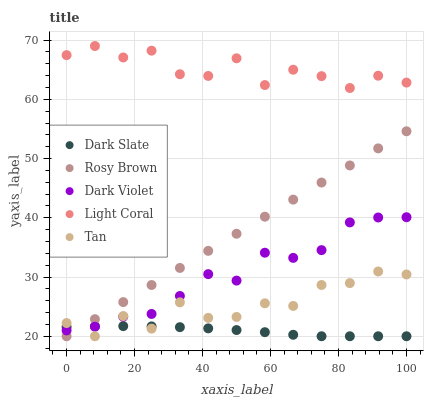Does Dark Slate have the minimum area under the curve?
Answer yes or no. Yes. Does Light Coral have the maximum area under the curve?
Answer yes or no. Yes. Does Tan have the minimum area under the curve?
Answer yes or no. No. Does Tan have the maximum area under the curve?
Answer yes or no. No. Is Rosy Brown the smoothest?
Answer yes or no. Yes. Is Light Coral the roughest?
Answer yes or no. Yes. Is Dark Slate the smoothest?
Answer yes or no. No. Is Dark Slate the roughest?
Answer yes or no. No. Does Dark Slate have the lowest value?
Answer yes or no. Yes. Does Dark Violet have the lowest value?
Answer yes or no. No. Does Light Coral have the highest value?
Answer yes or no. Yes. Does Tan have the highest value?
Answer yes or no. No. Is Tan less than Light Coral?
Answer yes or no. Yes. Is Light Coral greater than Tan?
Answer yes or no. Yes. Does Dark Violet intersect Tan?
Answer yes or no. Yes. Is Dark Violet less than Tan?
Answer yes or no. No. Is Dark Violet greater than Tan?
Answer yes or no. No. Does Tan intersect Light Coral?
Answer yes or no. No. 